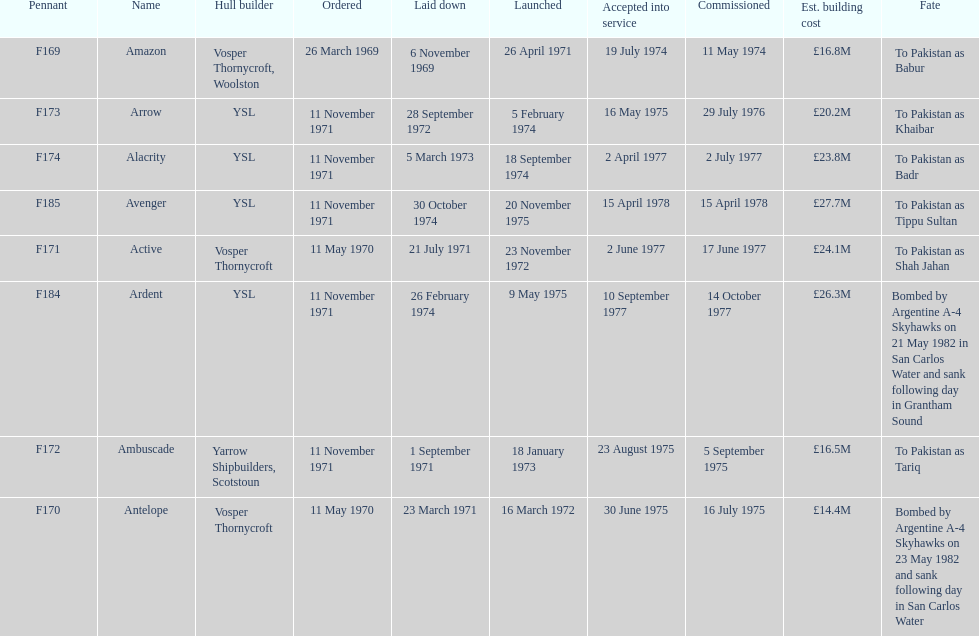How many ships were laid down in september? 2. 